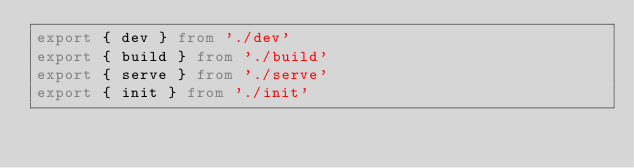<code> <loc_0><loc_0><loc_500><loc_500><_TypeScript_>export { dev } from './dev'
export { build } from './build'
export { serve } from './serve'
export { init } from './init'
</code> 